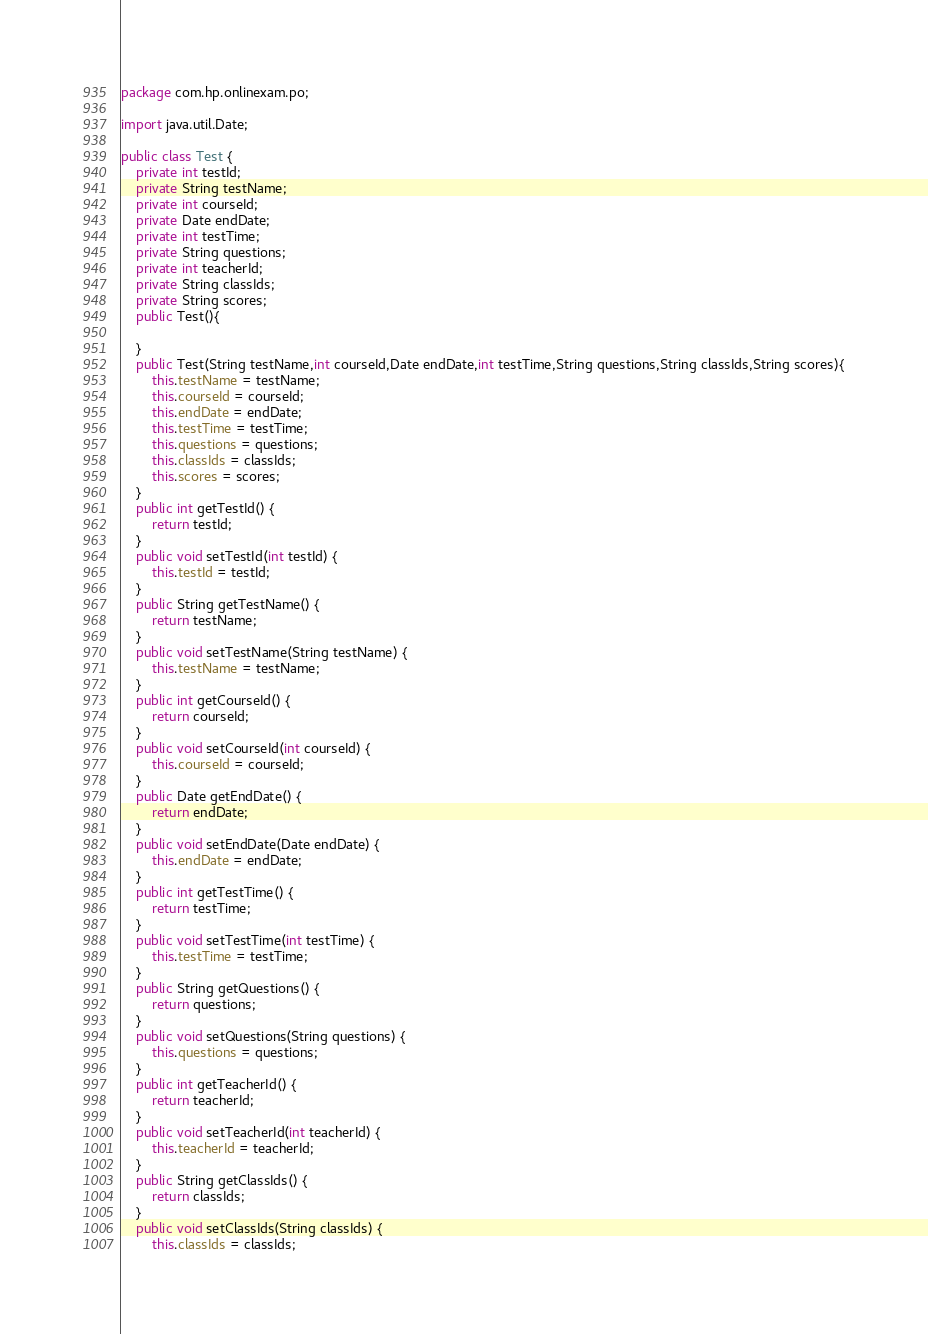<code> <loc_0><loc_0><loc_500><loc_500><_Java_>package com.hp.onlinexam.po;

import java.util.Date;

public class Test {
	private int testId;
	private String testName;
	private int courseId;
	private Date endDate;
	private int testTime;
	private String questions;
	private int teacherId;
	private String classIds;
	private String scores;
	public Test(){
		
	}
	public Test(String testName,int courseId,Date endDate,int testTime,String questions,String classIds,String scores){
		this.testName = testName;
		this.courseId = courseId;
		this.endDate = endDate;
		this.testTime = testTime;
		this.questions = questions;
		this.classIds = classIds;
		this.scores = scores;
	}
	public int getTestId() {
		return testId;
	}
	public void setTestId(int testId) {
		this.testId = testId;
	}
	public String getTestName() {
		return testName;
	}
	public void setTestName(String testName) {
		this.testName = testName;
	}
	public int getCourseId() {
		return courseId;
	}
	public void setCourseId(int courseId) {
		this.courseId = courseId;
	}
	public Date getEndDate() {
		return endDate;
	}
	public void setEndDate(Date endDate) {
		this.endDate = endDate;
	}
	public int getTestTime() {
		return testTime;
	}
	public void setTestTime(int testTime) {
		this.testTime = testTime;
	}
	public String getQuestions() {
		return questions;
	}
	public void setQuestions(String questions) {
		this.questions = questions;
	}
	public int getTeacherId() {
		return teacherId;
	}
	public void setTeacherId(int teacherId) {
		this.teacherId = teacherId;
	}
	public String getClassIds() {
		return classIds;
	}
	public void setClassIds(String classIds) {
		this.classIds = classIds;</code> 